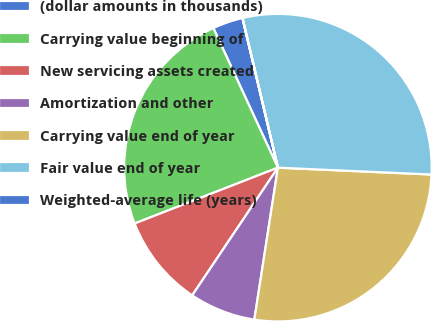Convert chart. <chart><loc_0><loc_0><loc_500><loc_500><pie_chart><fcel>(dollar amounts in thousands)<fcel>Carrying value beginning of<fcel>New servicing assets created<fcel>Amortization and other<fcel>Carrying value end of year<fcel>Fair value end of year<fcel>Weighted-average life (years)<nl><fcel>3.19%<fcel>24.02%<fcel>9.68%<fcel>6.96%<fcel>26.74%<fcel>29.41%<fcel>0.01%<nl></chart> 